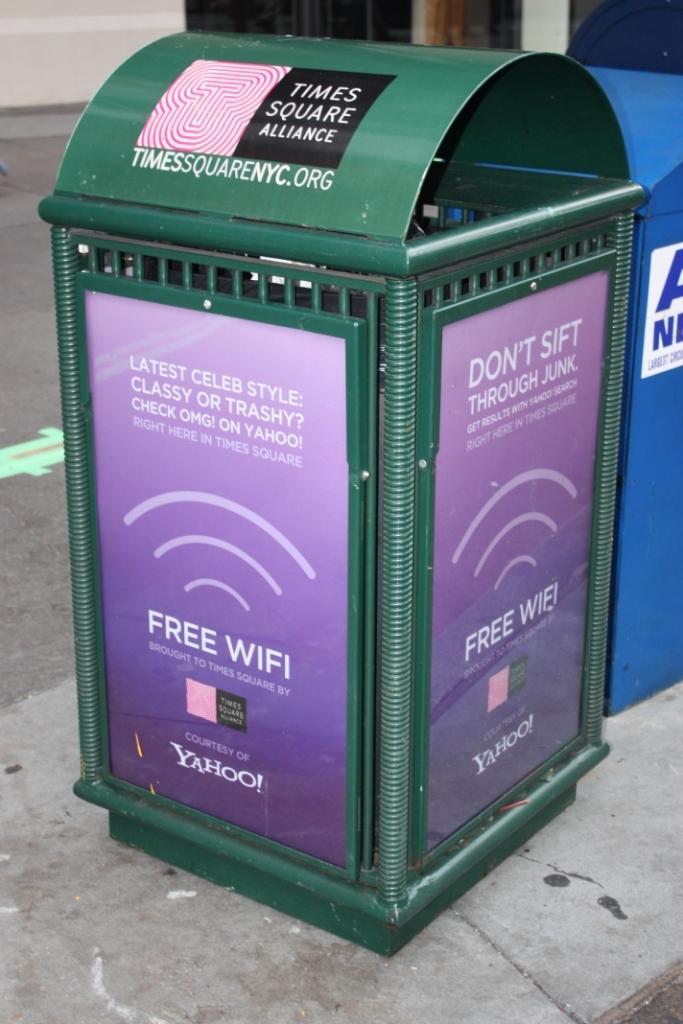<image>
Provide a brief description of the given image. Green trash can with a purple sign which says FREE WIFI. 